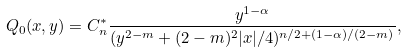Convert formula to latex. <formula><loc_0><loc_0><loc_500><loc_500>Q _ { 0 } ( x , y ) = C _ { n } ^ { * } \frac { y ^ { 1 - \alpha } } { ( y ^ { 2 - m } + ( 2 - m ) ^ { 2 } | x | / 4 ) ^ { n / 2 + ( 1 - \alpha ) / ( 2 - m ) } } ,</formula> 